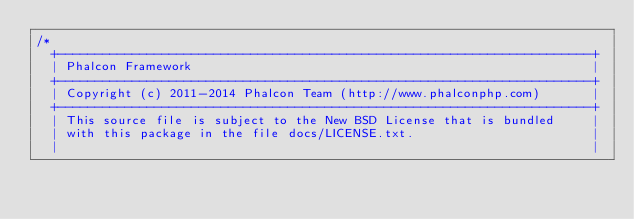<code> <loc_0><loc_0><loc_500><loc_500><_C_>/*
  +------------------------------------------------------------------------+
  | Phalcon Framework                                                      |
  +------------------------------------------------------------------------+
  | Copyright (c) 2011-2014 Phalcon Team (http://www.phalconphp.com)       |
  +------------------------------------------------------------------------+
  | This source file is subject to the New BSD License that is bundled     |
  | with this package in the file docs/LICENSE.txt.                        |
  |                                                                        |</code> 